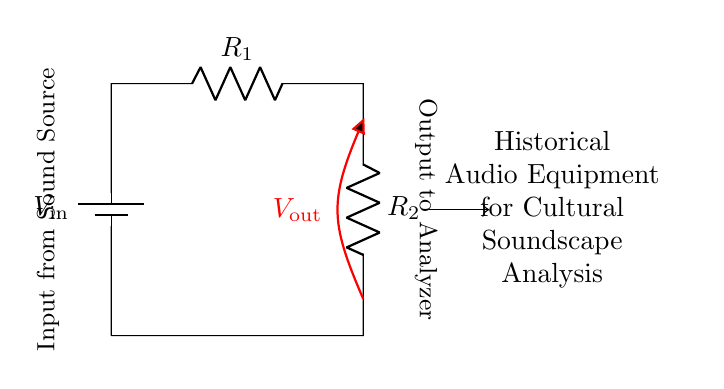What is the input voltage of the circuit? The input voltage is denoted as V_in, indicated by the battery symbol in the circuit.
Answer: V_in What are the two resistors in this circuit? The circuit displays two resistors labeled R_1 and R_2, connected in series.
Answer: R_1 and R_2 What is the output voltage labeled in the circuit? The output voltage is represented by V_out, which is indicated by the open voltage symbol between the resistors.
Answer: V_out How does changing R_1 affect V_out? Increasing R_1 while keeping R_2 constant raises the voltage across R_2, thus increasing V_out based on the voltage divider rule.
Answer: Increases V_out What type of circuit is this? This circuit is specifically a voltage divider, which is characterized by the arrangement of resistors and their interaction with input voltage.
Answer: Voltage divider If R_1 equals 1K ohm and R_2 equals 2K ohm, what is the ratio of R_1 to R_2? The ratio is found by dividing R_1 by R_2, which is 1 divided by 2, giving a simplified ratio of 1:2.
Answer: 1:2 